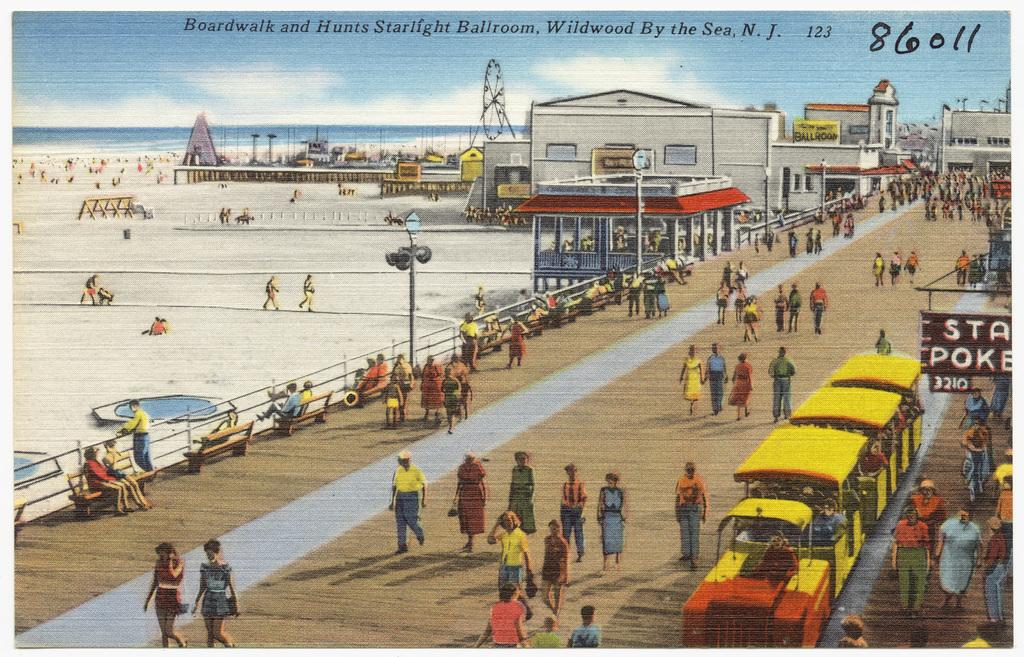<image>
Provide a brief description of the given image. the boardwalk and hunts starlight ballroom in a picture 